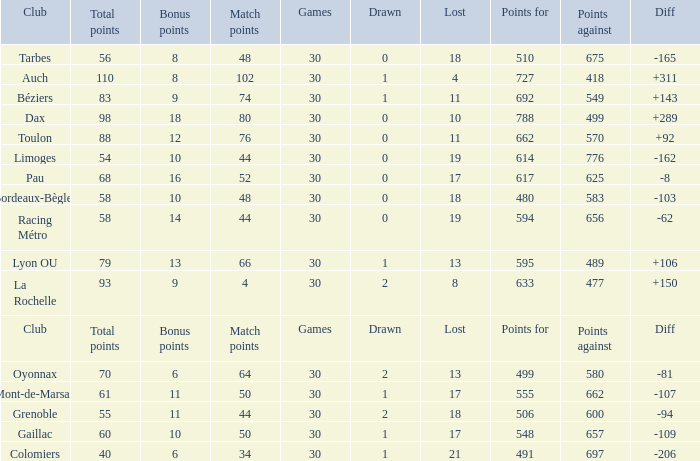What is the diff for a club that has a value of 662 for points for? 92.0. 